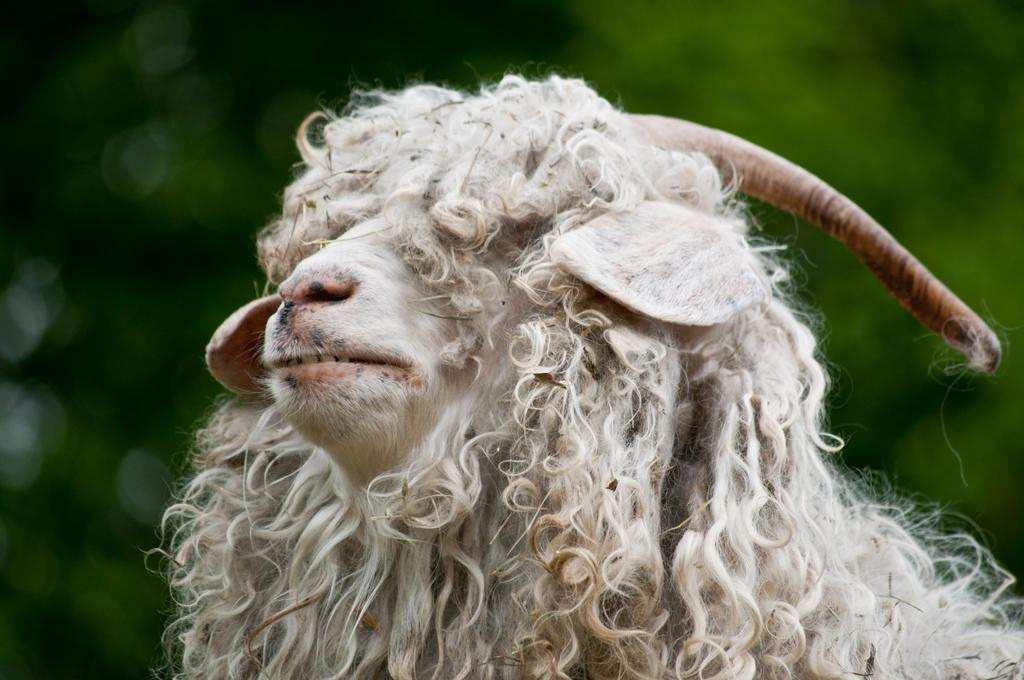What type of animal is present in the image? There is a sheep in the image. What type of decision does the zebra make in the image? There is no zebra present in the image, so it is not possible to determine any decisions made by a zebra. 